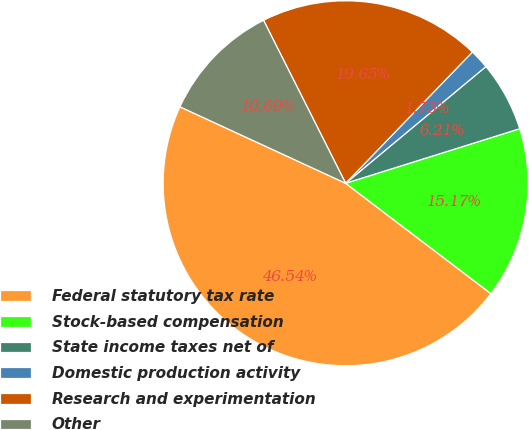Convert chart to OTSL. <chart><loc_0><loc_0><loc_500><loc_500><pie_chart><fcel>Federal statutory tax rate<fcel>Stock-based compensation<fcel>State income taxes net of<fcel>Domestic production activity<fcel>Research and experimentation<fcel>Other<nl><fcel>46.54%<fcel>15.17%<fcel>6.21%<fcel>1.73%<fcel>19.65%<fcel>10.69%<nl></chart> 